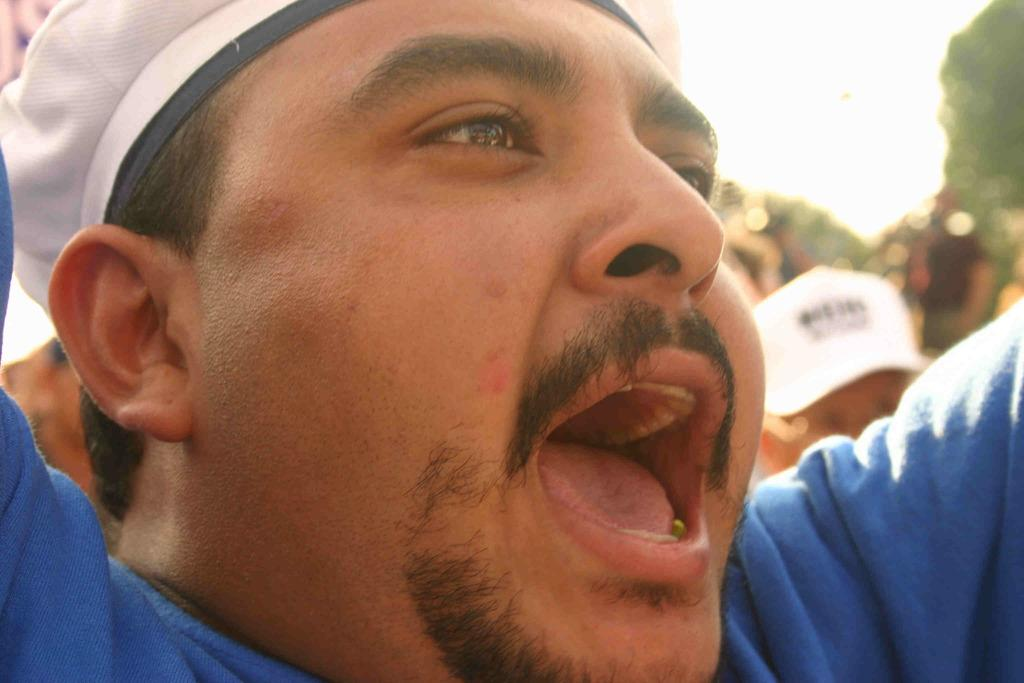What is the main subject of the image? There is a person in the image. What is the person wearing? The person is wearing a blue dress and a white cap. What is the person doing in the image? The person is screaming. Can you describe the background of the image? There are more people in the background of the image. How many rings can be seen on the person's fingers in the image? There is no mention of rings in the provided facts, so we cannot determine the number of rings on the person's fingers. What type of ocean can be seen in the background of the image? There is no ocean present in the image; it features a person and other people in the background. 